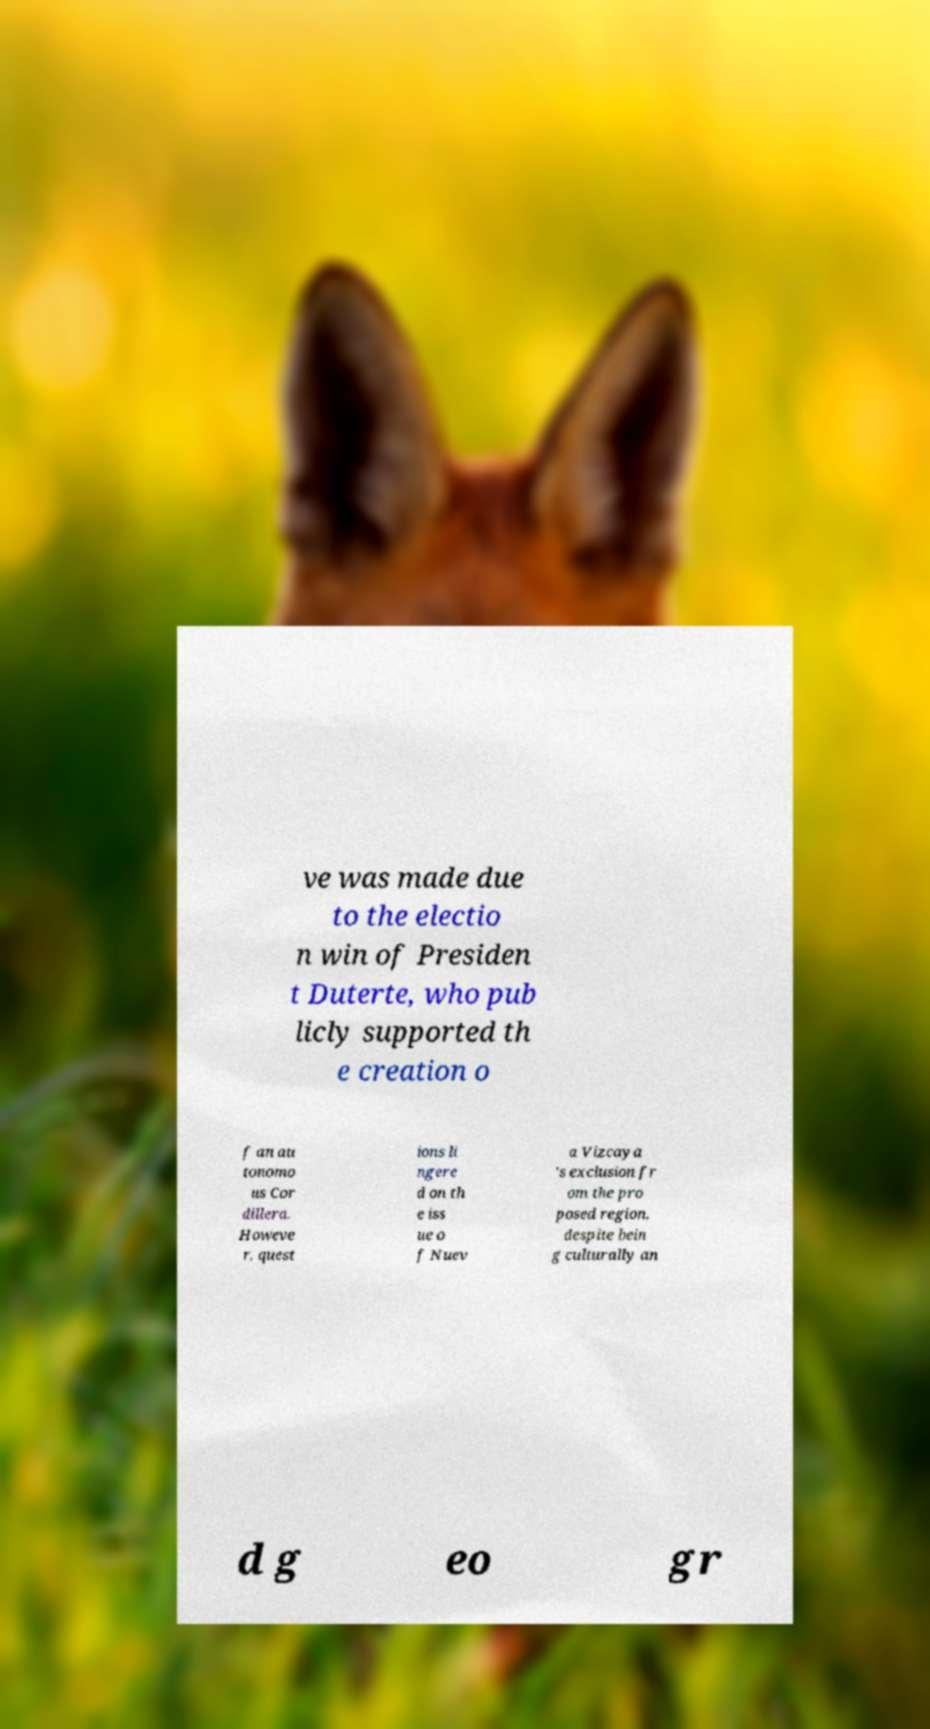For documentation purposes, I need the text within this image transcribed. Could you provide that? ve was made due to the electio n win of Presiden t Duterte, who pub licly supported th e creation o f an au tonomo us Cor dillera. Howeve r, quest ions li ngere d on th e iss ue o f Nuev a Vizcaya 's exclusion fr om the pro posed region, despite bein g culturally an d g eo gr 